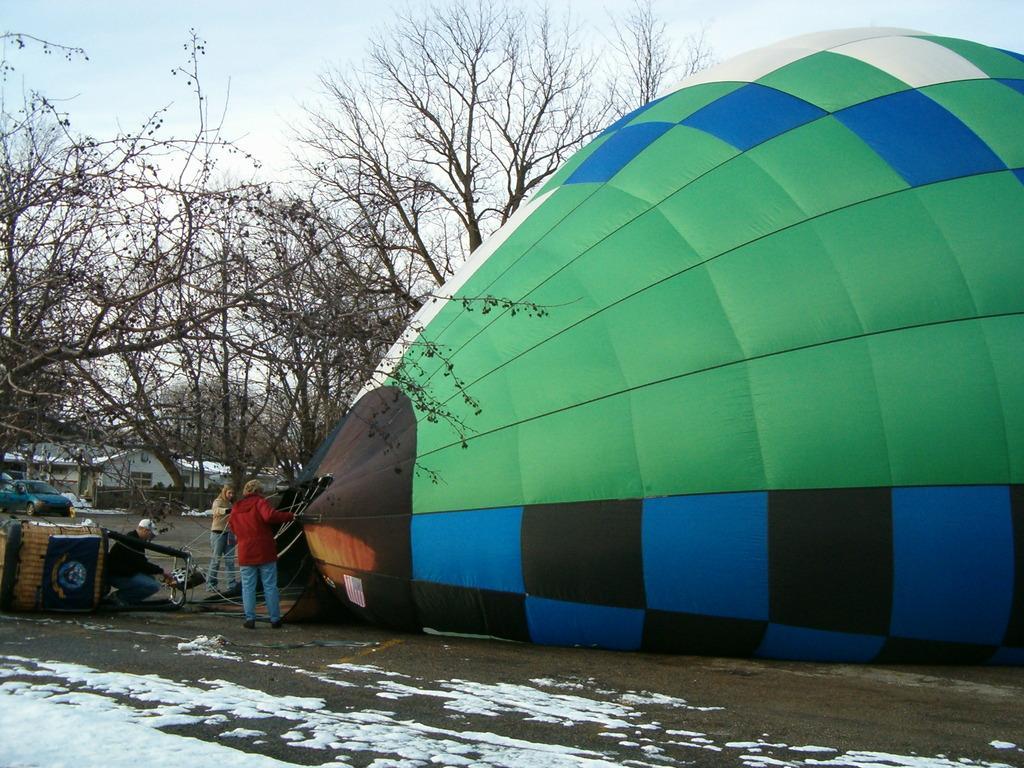Please provide a concise description of this image. This image consists of a parachute and there are many persons standing beside it. At the bottom, there is a road on which there is a snow. In the background, there are trees. 